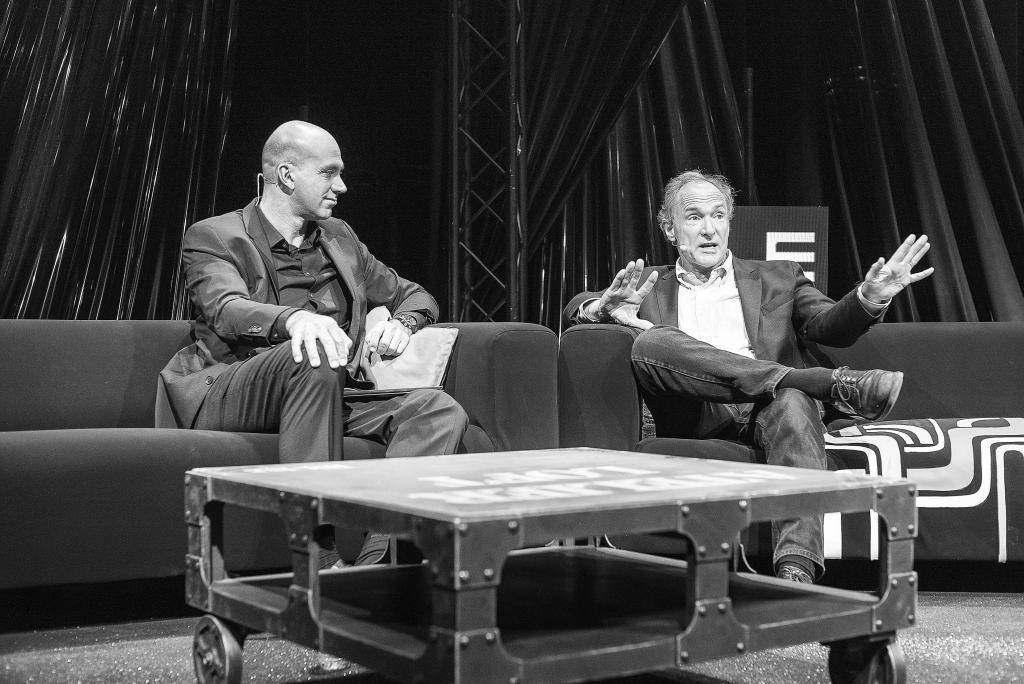In one or two sentences, can you explain what this image depicts? In this picture we can see two men sitting on sofa and talking on mic and in front of them there is table and in background we can see pillar, curtains. 